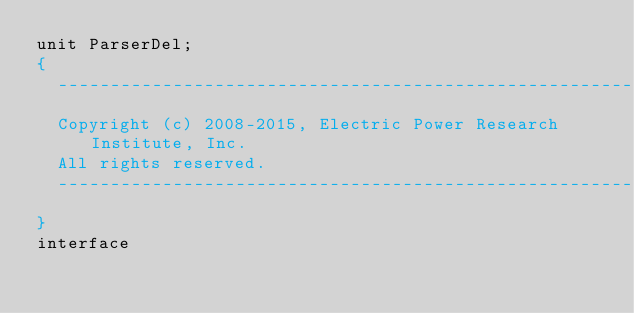<code> <loc_0><loc_0><loc_500><loc_500><_Pascal_>unit ParserDel;
{
  ----------------------------------------------------------
  Copyright (c) 2008-2015, Electric Power Research Institute, Inc.
  All rights reserved.
  ----------------------------------------------------------
}
interface
</code> 